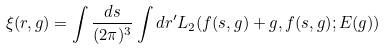Convert formula to latex. <formula><loc_0><loc_0><loc_500><loc_500>\xi ( { r } , { g } ) = \int \frac { d { s } } { ( 2 \pi ) ^ { 3 } } \int d { r } ^ { \prime } L _ { 2 } ( { f ( s , g ) + g } , { f ( s , g ) } ; E ( g ) )</formula> 